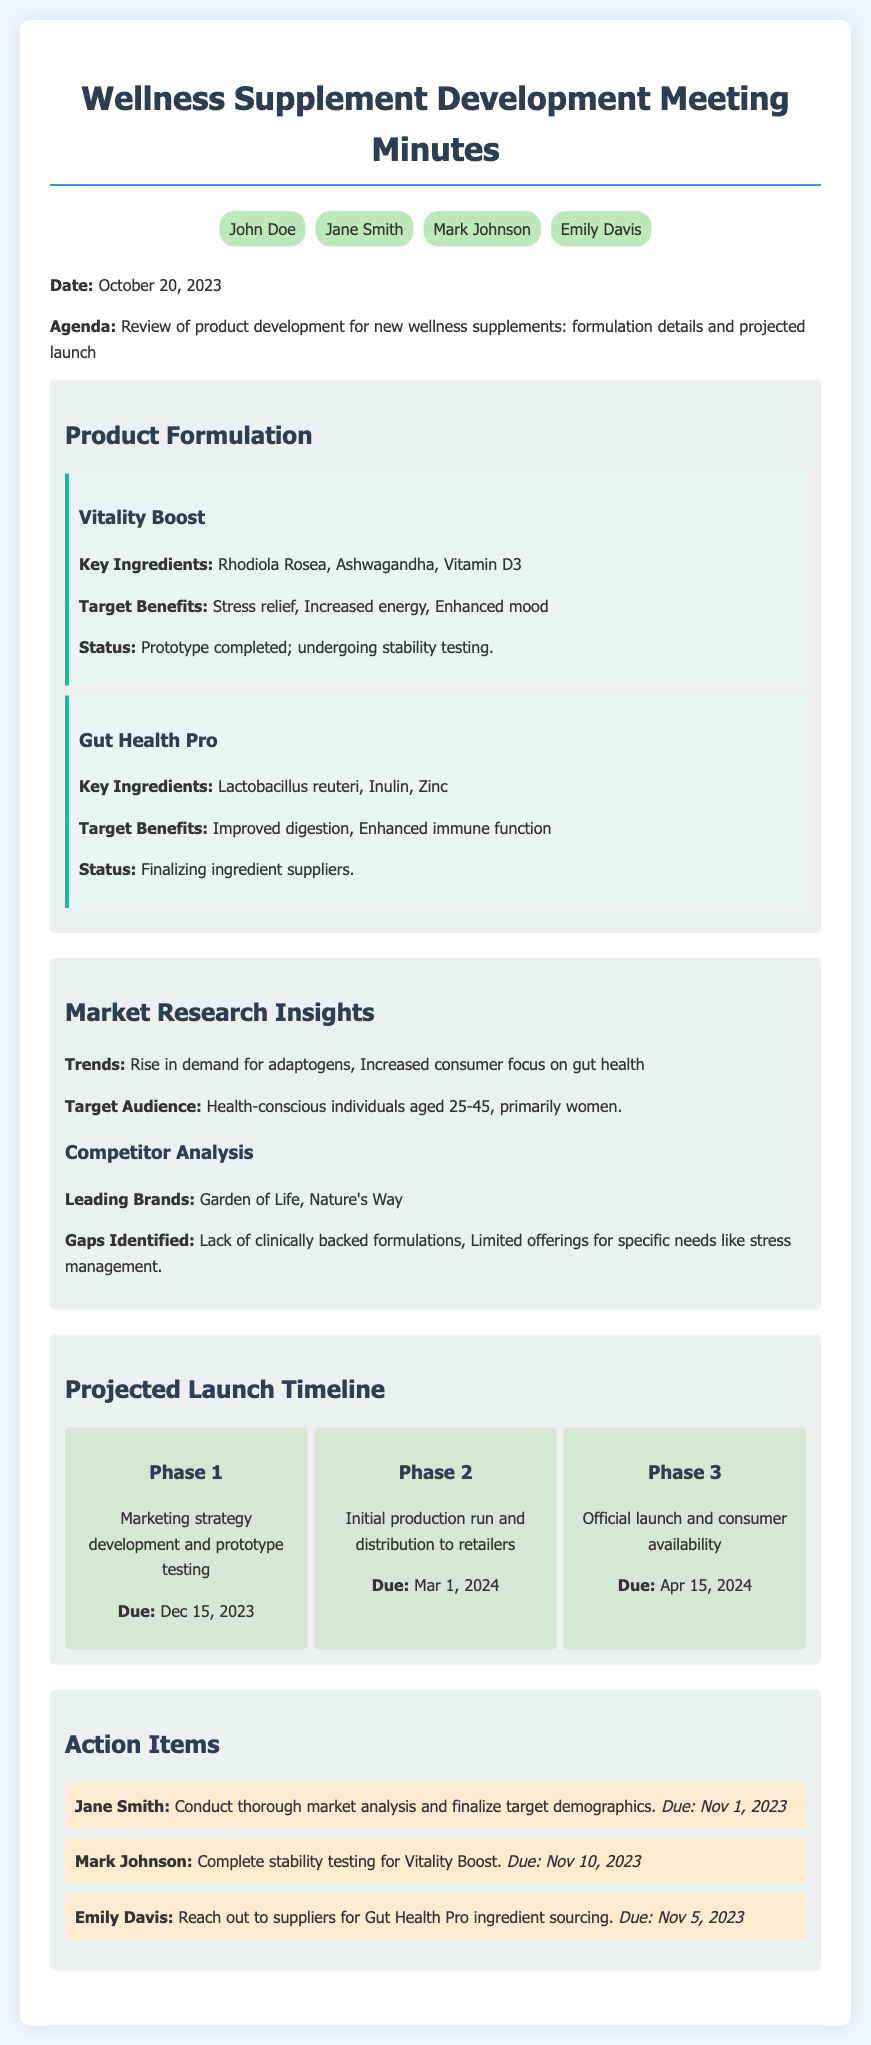What are the key ingredients in Vitality Boost? The key ingredients are listed under the Vitality Boost formulation section in the document.
Answer: Rhodiola Rosea, Ashwagandha, Vitamin D3 What is the target audience for the new supplements? The target audience is specified in the Market Research Insights section of the document.
Answer: Health-conscious individuals aged 25-45, primarily women When is the due date for the initial production run? The due date is found in the Projected Launch Timeline section.
Answer: Mar 1, 2024 What is the status of Gut Health Pro? The status is mentioned under the Gut Health Pro formulation details.
Answer: Finalizing ingredient suppliers Who is responsible for completing the stability testing for Vitality Boost? The action item specifies who is tasked with this responsibility.
Answer: Mark Johnson What are the target benefits of Gut Health Pro? The target benefits are outlined in the Gut Health Pro formulation section.
Answer: Improved digestion, Enhanced immune function In which phase is the marketing strategy development scheduled? The phases are listed sequentially in the Projected Launch Timeline section with activities.
Answer: Phase 1 What gaps were identified in the competitor analysis? The gaps are highlighted in the Market Research Insights section of the document.
Answer: Lack of clinically backed formulations, Limited offerings for specific needs like stress management 